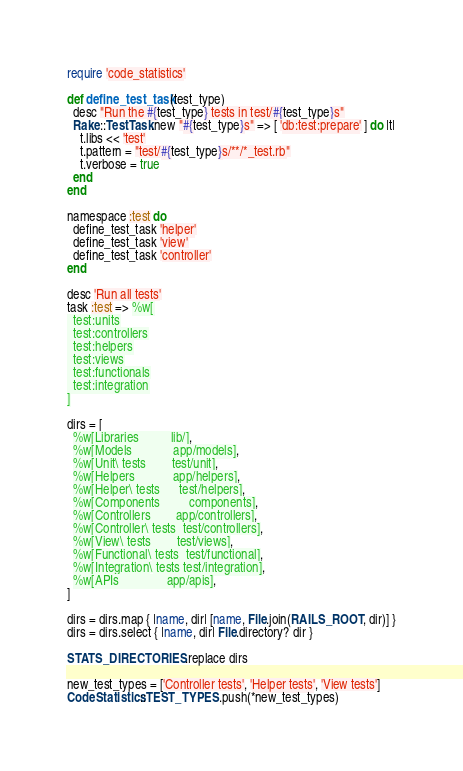Convert code to text. <code><loc_0><loc_0><loc_500><loc_500><_Ruby_>require 'code_statistics'

def define_test_task(test_type)
  desc "Run the #{test_type} tests in test/#{test_type}s"
  Rake::TestTask.new "#{test_type}s" => [ 'db:test:prepare' ] do |t|
    t.libs << 'test'
    t.pattern = "test/#{test_type}s/**/*_test.rb"
    t.verbose = true
  end
end

namespace :test do
  define_test_task 'helper'
  define_test_task 'view'
  define_test_task 'controller'
end

desc 'Run all tests'
task :test => %w[
  test:units
  test:controllers
  test:helpers
  test:views
  test:functionals
  test:integration
]

dirs = [
  %w[Libraries          lib/],
  %w[Models             app/models],
  %w[Unit\ tests        test/unit],
  %w[Helpers            app/helpers],
  %w[Helper\ tests      test/helpers],
  %w[Components         components],
  %w[Controllers        app/controllers],
  %w[Controller\ tests  test/controllers],
  %w[View\ tests        test/views],
  %w[Functional\ tests  test/functional],
  %w[Integration\ tests test/integration],
  %w[APIs               app/apis],
]

dirs = dirs.map { |name, dir| [name, File.join(RAILS_ROOT, dir)] }
dirs = dirs.select { |name, dir| File.directory? dir }

STATS_DIRECTORIES.replace dirs

new_test_types = ['Controller tests', 'Helper tests', 'View tests']
CodeStatistics::TEST_TYPES.push(*new_test_types)

</code> 